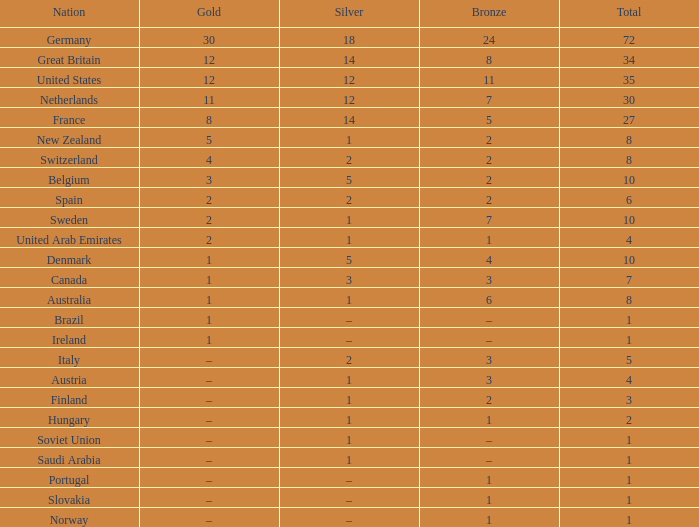What is Gold, when Bronze is 11? 12.0. 